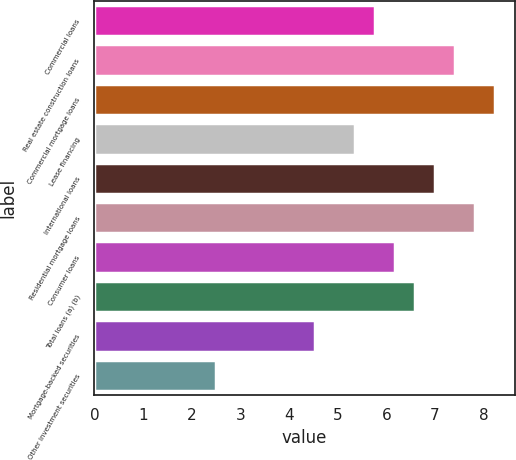<chart> <loc_0><loc_0><loc_500><loc_500><bar_chart><fcel>Commercial loans<fcel>Real estate construction loans<fcel>Commercial mortgage loans<fcel>Lease financing<fcel>International loans<fcel>Residential mortgage loans<fcel>Consumer loans<fcel>Total loans (a) (b)<fcel>Mortgage-backed securities<fcel>Other investment securities<nl><fcel>5.77<fcel>7.41<fcel>8.23<fcel>5.36<fcel>7<fcel>7.82<fcel>6.18<fcel>6.59<fcel>4.54<fcel>2.49<nl></chart> 